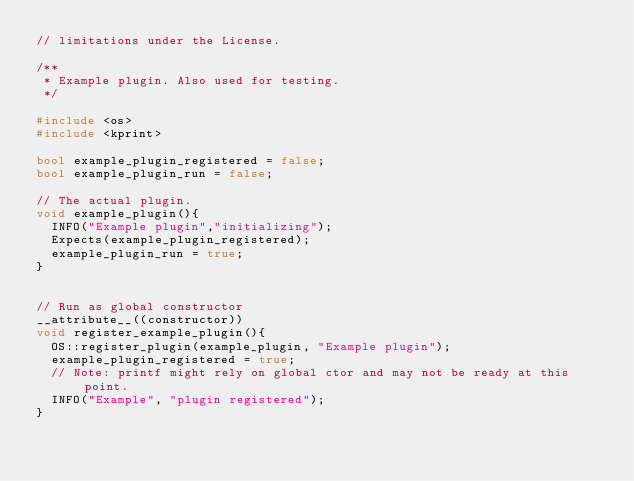<code> <loc_0><loc_0><loc_500><loc_500><_C++_>// limitations under the License.

/**
 * Example plugin. Also used for testing.
 */

#include <os>
#include <kprint>

bool example_plugin_registered = false;
bool example_plugin_run = false;

// The actual plugin.
void example_plugin(){
  INFO("Example plugin","initializing");
  Expects(example_plugin_registered);
  example_plugin_run = true;
}


// Run as global constructor
__attribute__((constructor))
void register_example_plugin(){
  OS::register_plugin(example_plugin, "Example plugin");
  example_plugin_registered = true;
  // Note: printf might rely on global ctor and may not be ready at this point.
  INFO("Example", "plugin registered");
}
</code> 